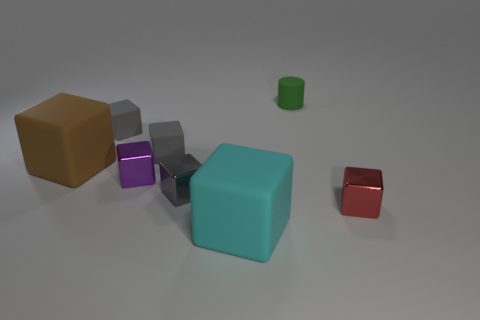What is the material of the big thing that is behind the big block to the right of the small block left of the tiny purple block?
Your answer should be compact. Rubber. Is the material of the large cyan thing the same as the large thing behind the tiny purple cube?
Offer a very short reply. Yes. There is another big object that is the same shape as the brown object; what is it made of?
Offer a terse response. Rubber. Are there more rubber objects behind the purple metallic object than small purple metal objects in front of the green rubber thing?
Provide a short and direct response. Yes. What is the shape of the large brown object that is made of the same material as the cyan cube?
Offer a terse response. Cube. How many other objects are the same shape as the tiny green object?
Ensure brevity in your answer.  0. There is a small gray object that is in front of the large brown rubber object; what is its shape?
Give a very brief answer. Cube. What is the color of the cylinder?
Make the answer very short. Green. How many other objects are there of the same size as the cylinder?
Offer a terse response. 5. There is a big object that is in front of the object that is right of the small green cylinder; what is its material?
Your answer should be very brief. Rubber. 